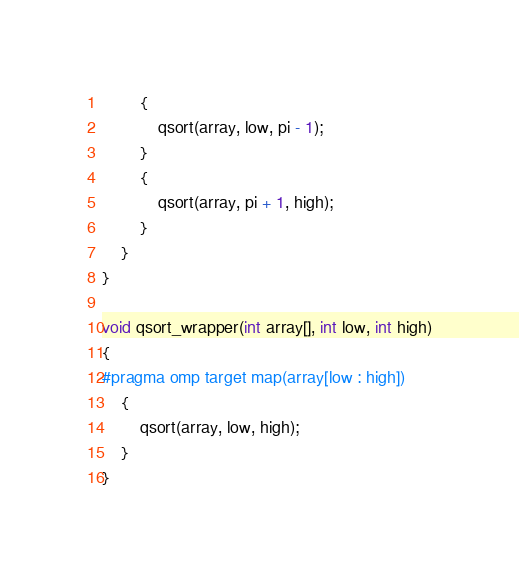Convert code to text. <code><loc_0><loc_0><loc_500><loc_500><_C++_>		{
			qsort(array, low, pi - 1);
		}
		{
			qsort(array, pi + 1, high);
		}
	}
}

void qsort_wrapper(int array[], int low, int high)
{
#pragma omp target map(array[low : high])
    {
        qsort(array, low, high);
    }
}


</code> 